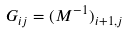Convert formula to latex. <formula><loc_0><loc_0><loc_500><loc_500>G _ { i j } = ( M ^ { - 1 } ) _ { i + 1 , j }</formula> 